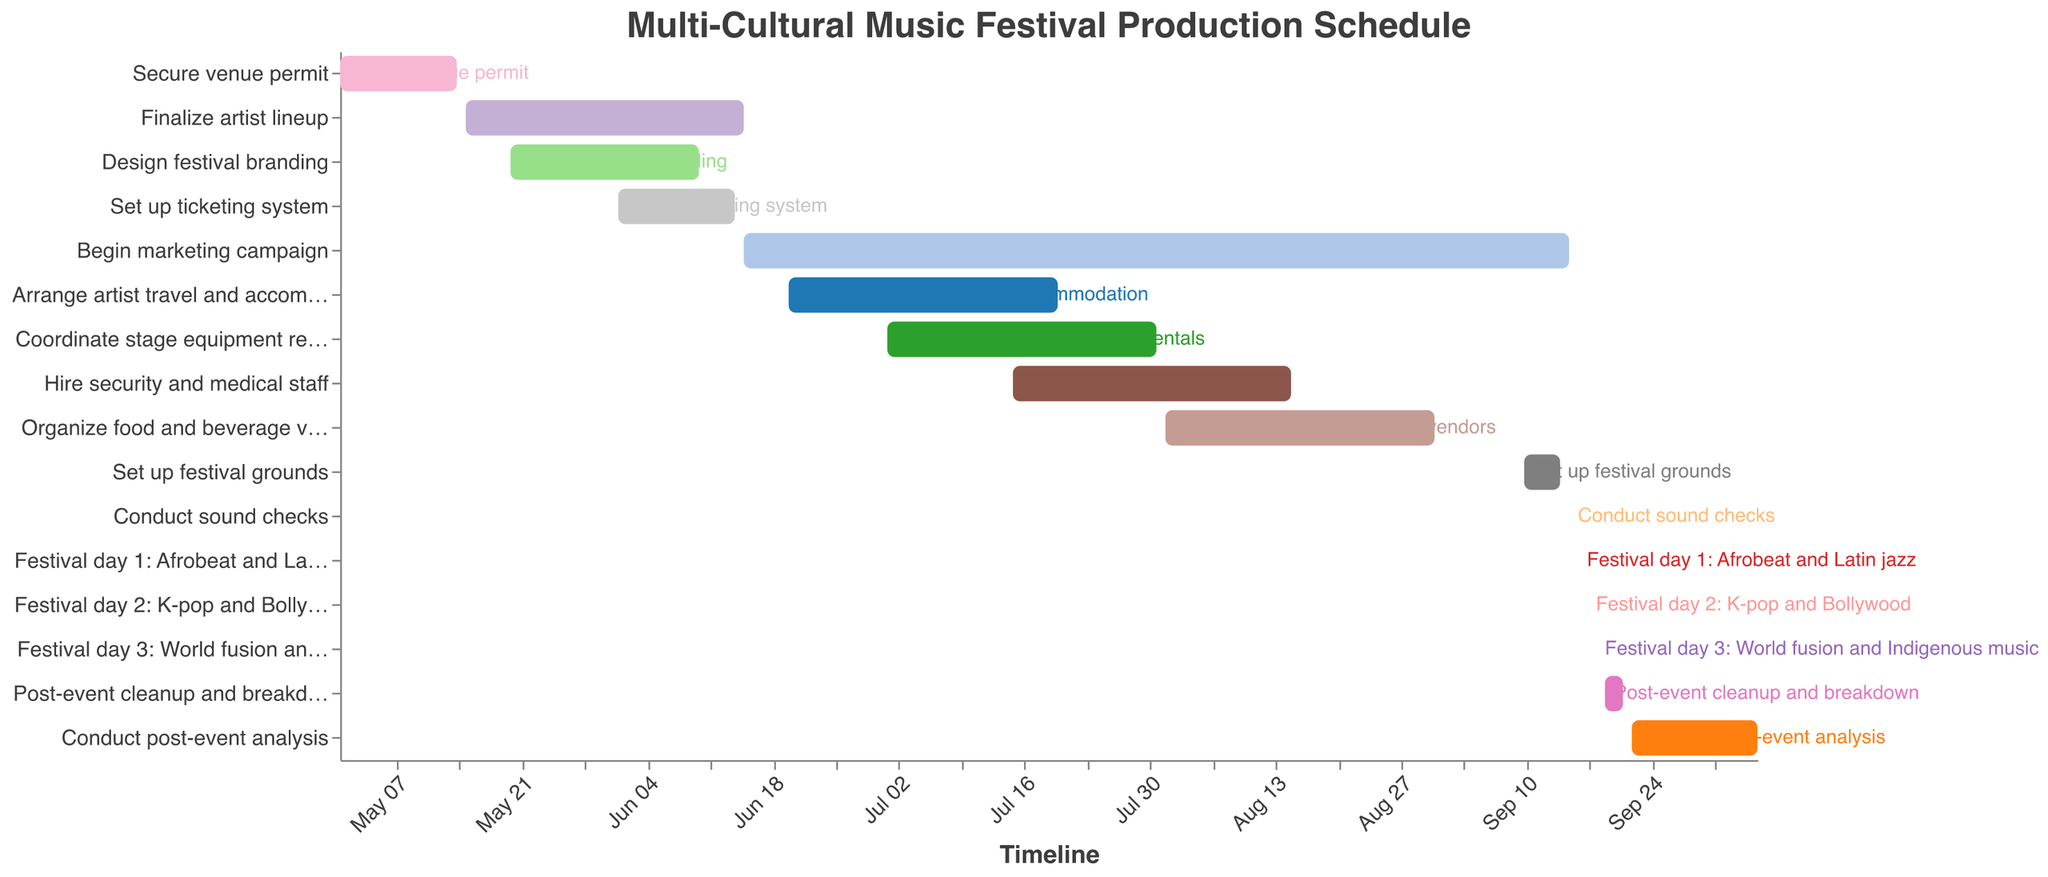What is the time frame for coordinating stage equipment rentals? To find the time frame for coordinating stage equipment rentals, we need to look for the specific task labeled "Coordinate stage equipment rentals" and check its start and end dates. The start date is 2023-07-01, and the end date is 2023-07-31. Therefore, the time frame is from July 1 to July 31, 2023.
Answer: July 1 to July 31, 2023 Which task lasts the longest? By examining the length of the bars corresponding to each task, we can identify the one that spans the most dates. The task "Begin marketing campaign" starts on 2023-06-15 and ends on 2023-09-15, lasting for a total of three months, which is longer than any other task in the chart.
Answer: Begin marketing campaign How many tasks are scheduled to start in June 2023? To determine how many tasks start in June 2023, we count the number of tasks with a start date in June. These tasks are "Finalize artist lineup", "Set up ticketing system", "Begin marketing campaign", and "Arrange artist travel and accommodation".
Answer: 4 Which tasks are scheduled to take place simultaneously? To identify tasks that occur simultaneously, look for overlapping bars on the timeline. For example, "Begin marketing campaign" overlaps with "Arrange artist travel and accommodation", "Coordinate stage equipment rentals", "Hire security and medical staff", and "Organize food and beverage vendors".
Answer: Begin marketing campaign and Arrange artist travel and accommodation, Coordinate stage equipment rentals, Hire security and medical staff, Organize food and beverage vendors What is the duration of the task "Hire security and medical staff"? To find the duration of "Hire security and medical staff", we look at the start and end dates, which are 2023-07-15 and 2023-08-15 respectively. The duration is therefore 31 days.
Answer: 31 days When is the post-event cleanup and breakdown scheduled? The task "Post-event cleanup and breakdown" is scheduled from 2023-09-19 to 2023-09-21. So, it spans from September 19 to September 21, 2023.
Answer: September 19 to September 21, 2023 Which tasks need to be completed before the marketing campaign begins? The marketing campaign begins on 2023-06-15. To find the tasks that need to be completed before this date, look at tasks ending before 2023-06-15: "Secure venue permit", "Finalize artist lineup" (starts on 2023-05-15), "Design festival branding", and "Set up ticketing system".
Answer: Secure venue permit, Finalize artist lineup, Design festival branding, Set up ticketing system What are the specific dates for the three festival days and the genres featured on each day? The festival days and their respective genres are listed as follows: "Festival day 1: Afrobeat and Latin jazz" on 2023-09-16, "Festival day 2: K-pop and Bollywood" on 2023-09-17, and "Festival day 3: World fusion and Indigenous music" on 2023-09-18.
Answer: September 16: Afrobeat and Latin jazz, September 17: K-pop and Bollywood, September 18: World fusion and Indigenous music Which task has the shortest duration? By comparing the lengths of the bars, "Conduct sound checks" has the shortest duration as it is scheduled only for 2023-09-15.
Answer: Conduct sound checks 